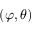<formula> <loc_0><loc_0><loc_500><loc_500>\left ( \varphi , \theta \right )</formula> 